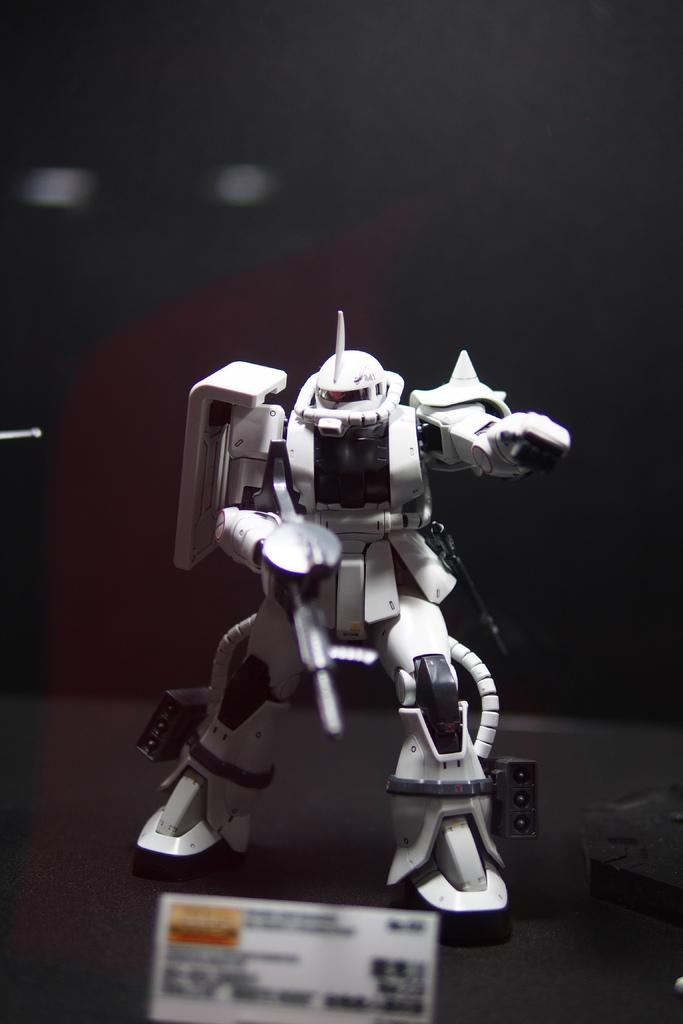What is the main subject in the middle of the image? There is a toy robot in the middle of the image. What is located at the bottom of the image? There is a paper at the bottom of the image. How would you describe the background of the image? The background of the image is blurry. Can you see an example of an island in the image? There is no island present in the image. Is there a swing visible in the image? There is no swing present in the image. 